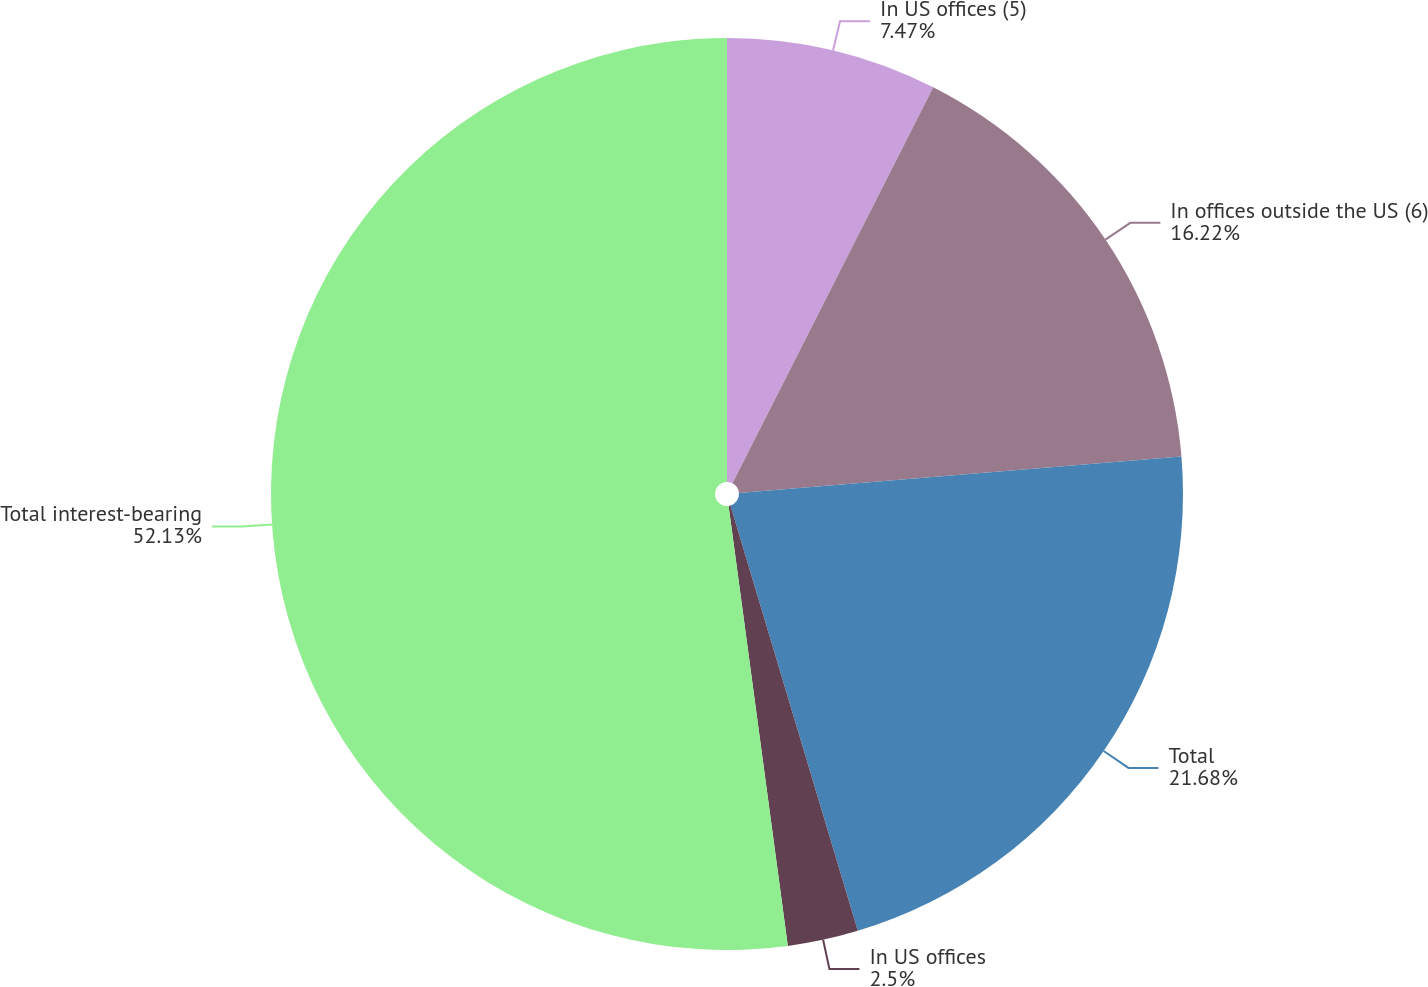<chart> <loc_0><loc_0><loc_500><loc_500><pie_chart><fcel>In US offices (5)<fcel>In offices outside the US (6)<fcel>Total<fcel>In US offices<fcel>Total interest-bearing<nl><fcel>7.47%<fcel>16.22%<fcel>21.68%<fcel>2.5%<fcel>52.13%<nl></chart> 